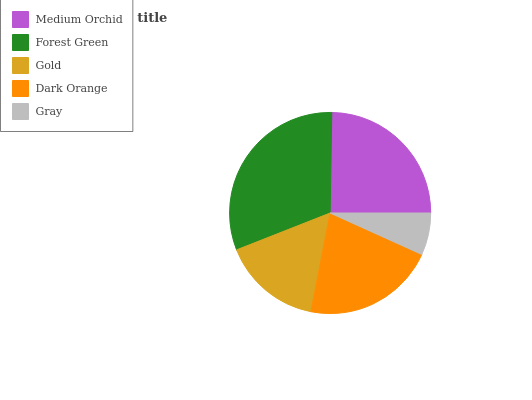Is Gray the minimum?
Answer yes or no. Yes. Is Forest Green the maximum?
Answer yes or no. Yes. Is Gold the minimum?
Answer yes or no. No. Is Gold the maximum?
Answer yes or no. No. Is Forest Green greater than Gold?
Answer yes or no. Yes. Is Gold less than Forest Green?
Answer yes or no. Yes. Is Gold greater than Forest Green?
Answer yes or no. No. Is Forest Green less than Gold?
Answer yes or no. No. Is Dark Orange the high median?
Answer yes or no. Yes. Is Dark Orange the low median?
Answer yes or no. Yes. Is Gray the high median?
Answer yes or no. No. Is Forest Green the low median?
Answer yes or no. No. 